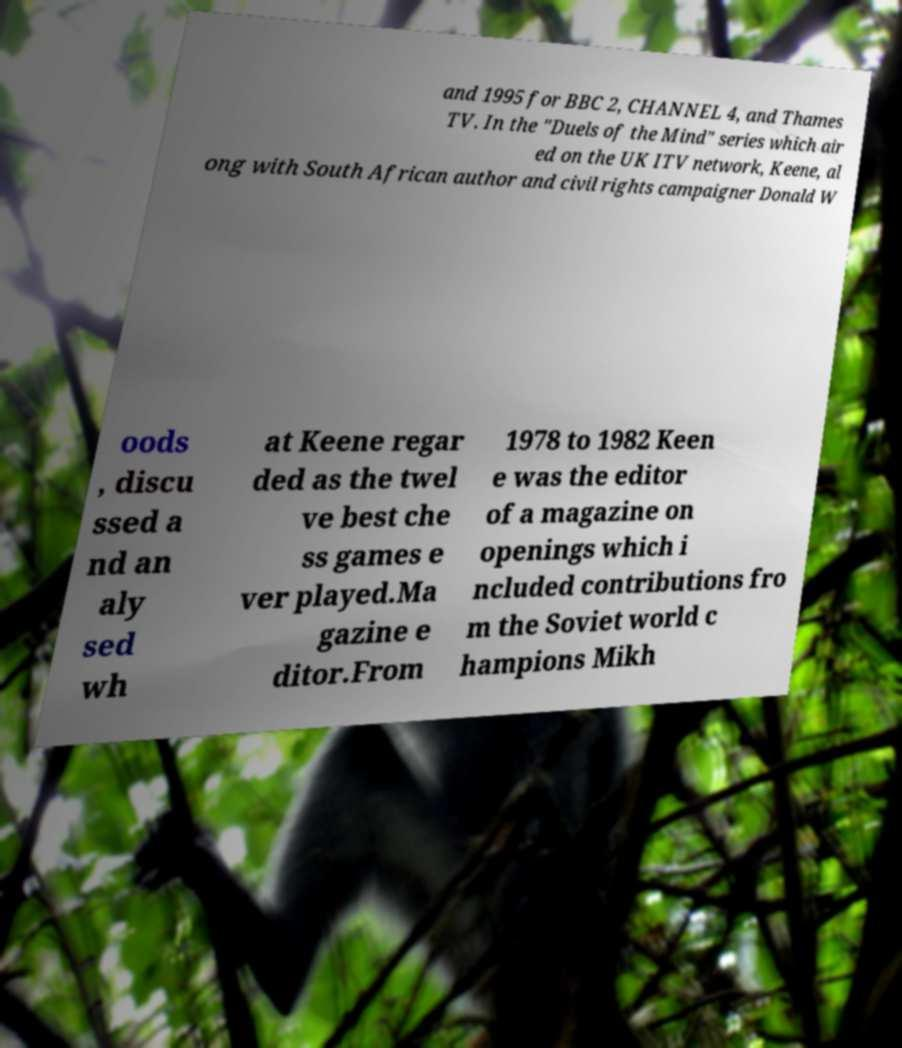I need the written content from this picture converted into text. Can you do that? and 1995 for BBC 2, CHANNEL 4, and Thames TV. In the "Duels of the Mind" series which air ed on the UK ITV network, Keene, al ong with South African author and civil rights campaigner Donald W oods , discu ssed a nd an aly sed wh at Keene regar ded as the twel ve best che ss games e ver played.Ma gazine e ditor.From 1978 to 1982 Keen e was the editor of a magazine on openings which i ncluded contributions fro m the Soviet world c hampions Mikh 